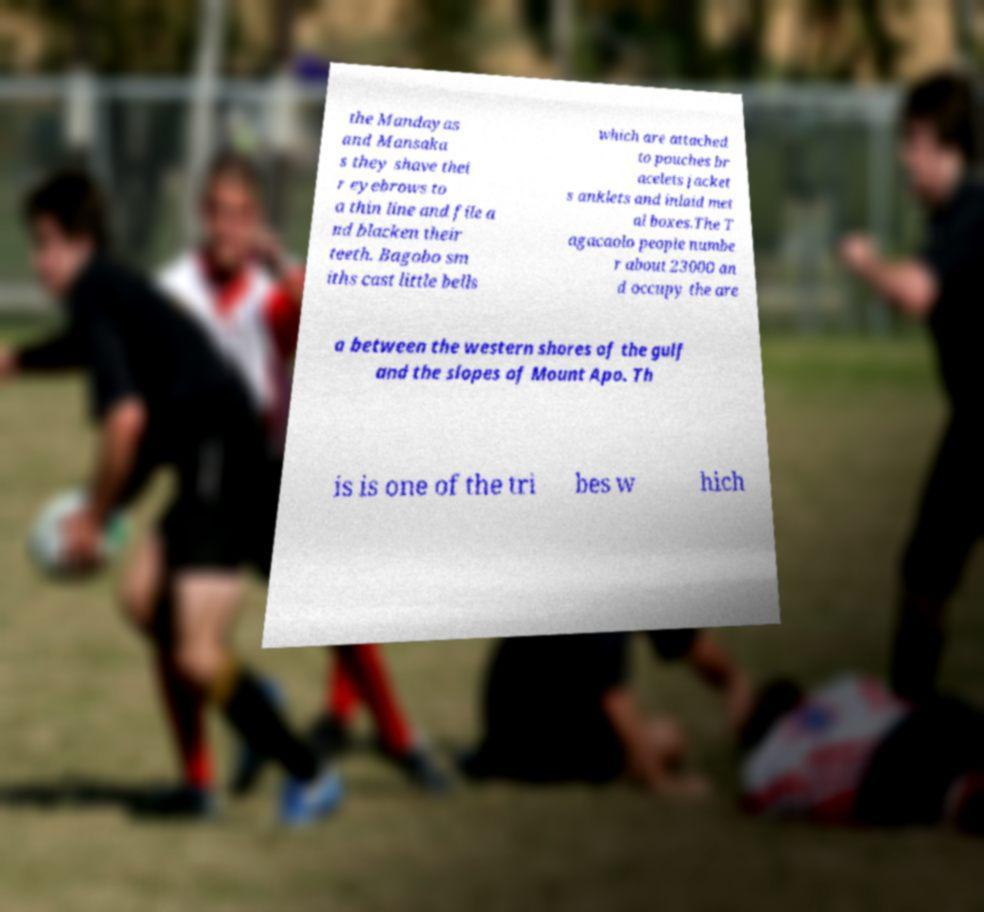Can you read and provide the text displayed in the image?This photo seems to have some interesting text. Can you extract and type it out for me? the Mandayas and Mansaka s they shave thei r eyebrows to a thin line and file a nd blacken their teeth. Bagobo sm iths cast little bells which are attached to pouches br acelets jacket s anklets and inlaid met al boxes.The T agacaolo people numbe r about 23000 an d occupy the are a between the western shores of the gulf and the slopes of Mount Apo. Th is is one of the tri bes w hich 